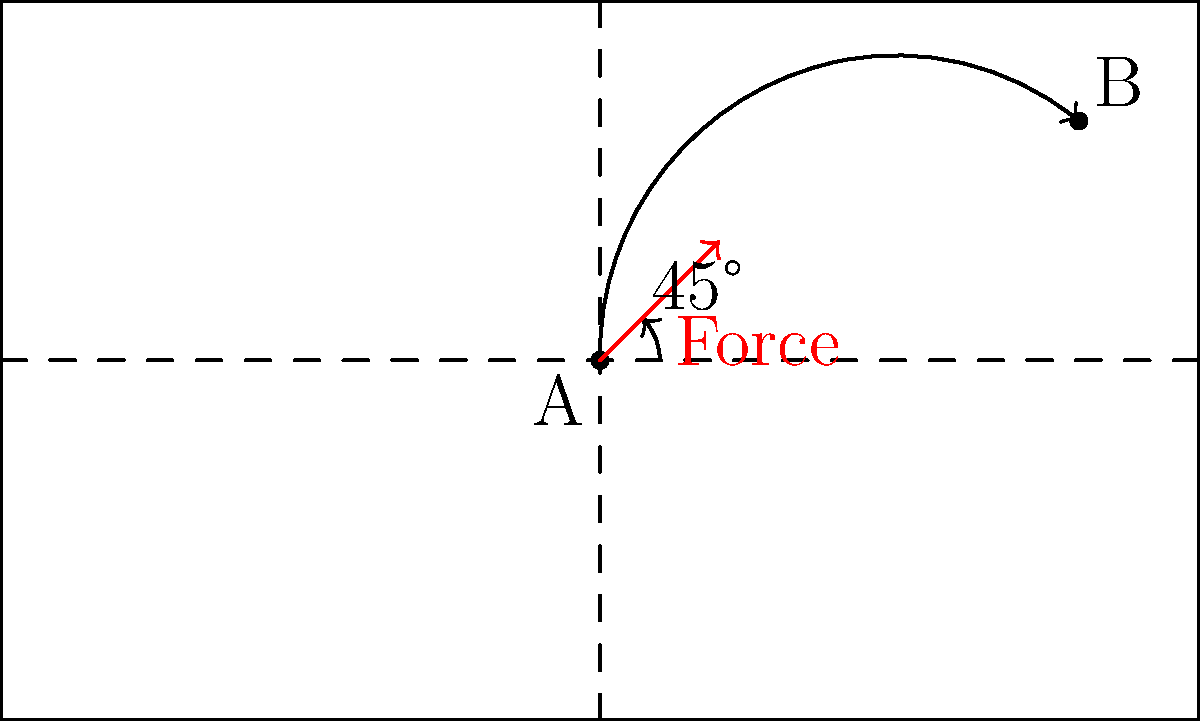As a soccer coach, you're demonstrating a kick to your team. The ball is at point A, and you want it to reach point B. If you kick the ball at a 45-degree angle with a certain force, as shown in the diagram, which of the following factors would most significantly affect the ball's trajectory to ensure it reaches point B?

a) Wind speed
b) Ball spin
c) Initial velocity
d) Field surface Let's analyze this step-by-step:

1) The ball's trajectory is determined by several factors, but the most crucial ones are:
   - Initial angle of the kick
   - Initial velocity of the ball

2) In this case, the angle is fixed at 45 degrees, which is generally considered optimal for maximum range in projectile motion.

3) The path shown is a parabolic trajectory, typical for objects under the influence of gravity and neglecting air resistance.

4) To reach point B, the most critical factor is the initial velocity, which is directly related to the force applied to the ball.

5) The equation for the range of a projectile is:

   $$R = \frac{v_0^2 \sin(2\theta)}{g}$$

   Where $R$ is the range, $v_0$ is the initial velocity, $\theta$ is the angle, and $g$ is the acceleration due to gravity.

6) Given that $\theta$ is fixed, the only variable that can significantly change the range is $v_0$, which is determined by the force of the kick.

7) While wind speed, ball spin, and field surface can affect the ball's trajectory, their impact is generally less significant compared to the initial velocity for the distances typically involved in soccer.

Therefore, the initial velocity, which is directly related to the force of the kick, is the most significant factor in ensuring the ball reaches point B.
Answer: c) Initial velocity 